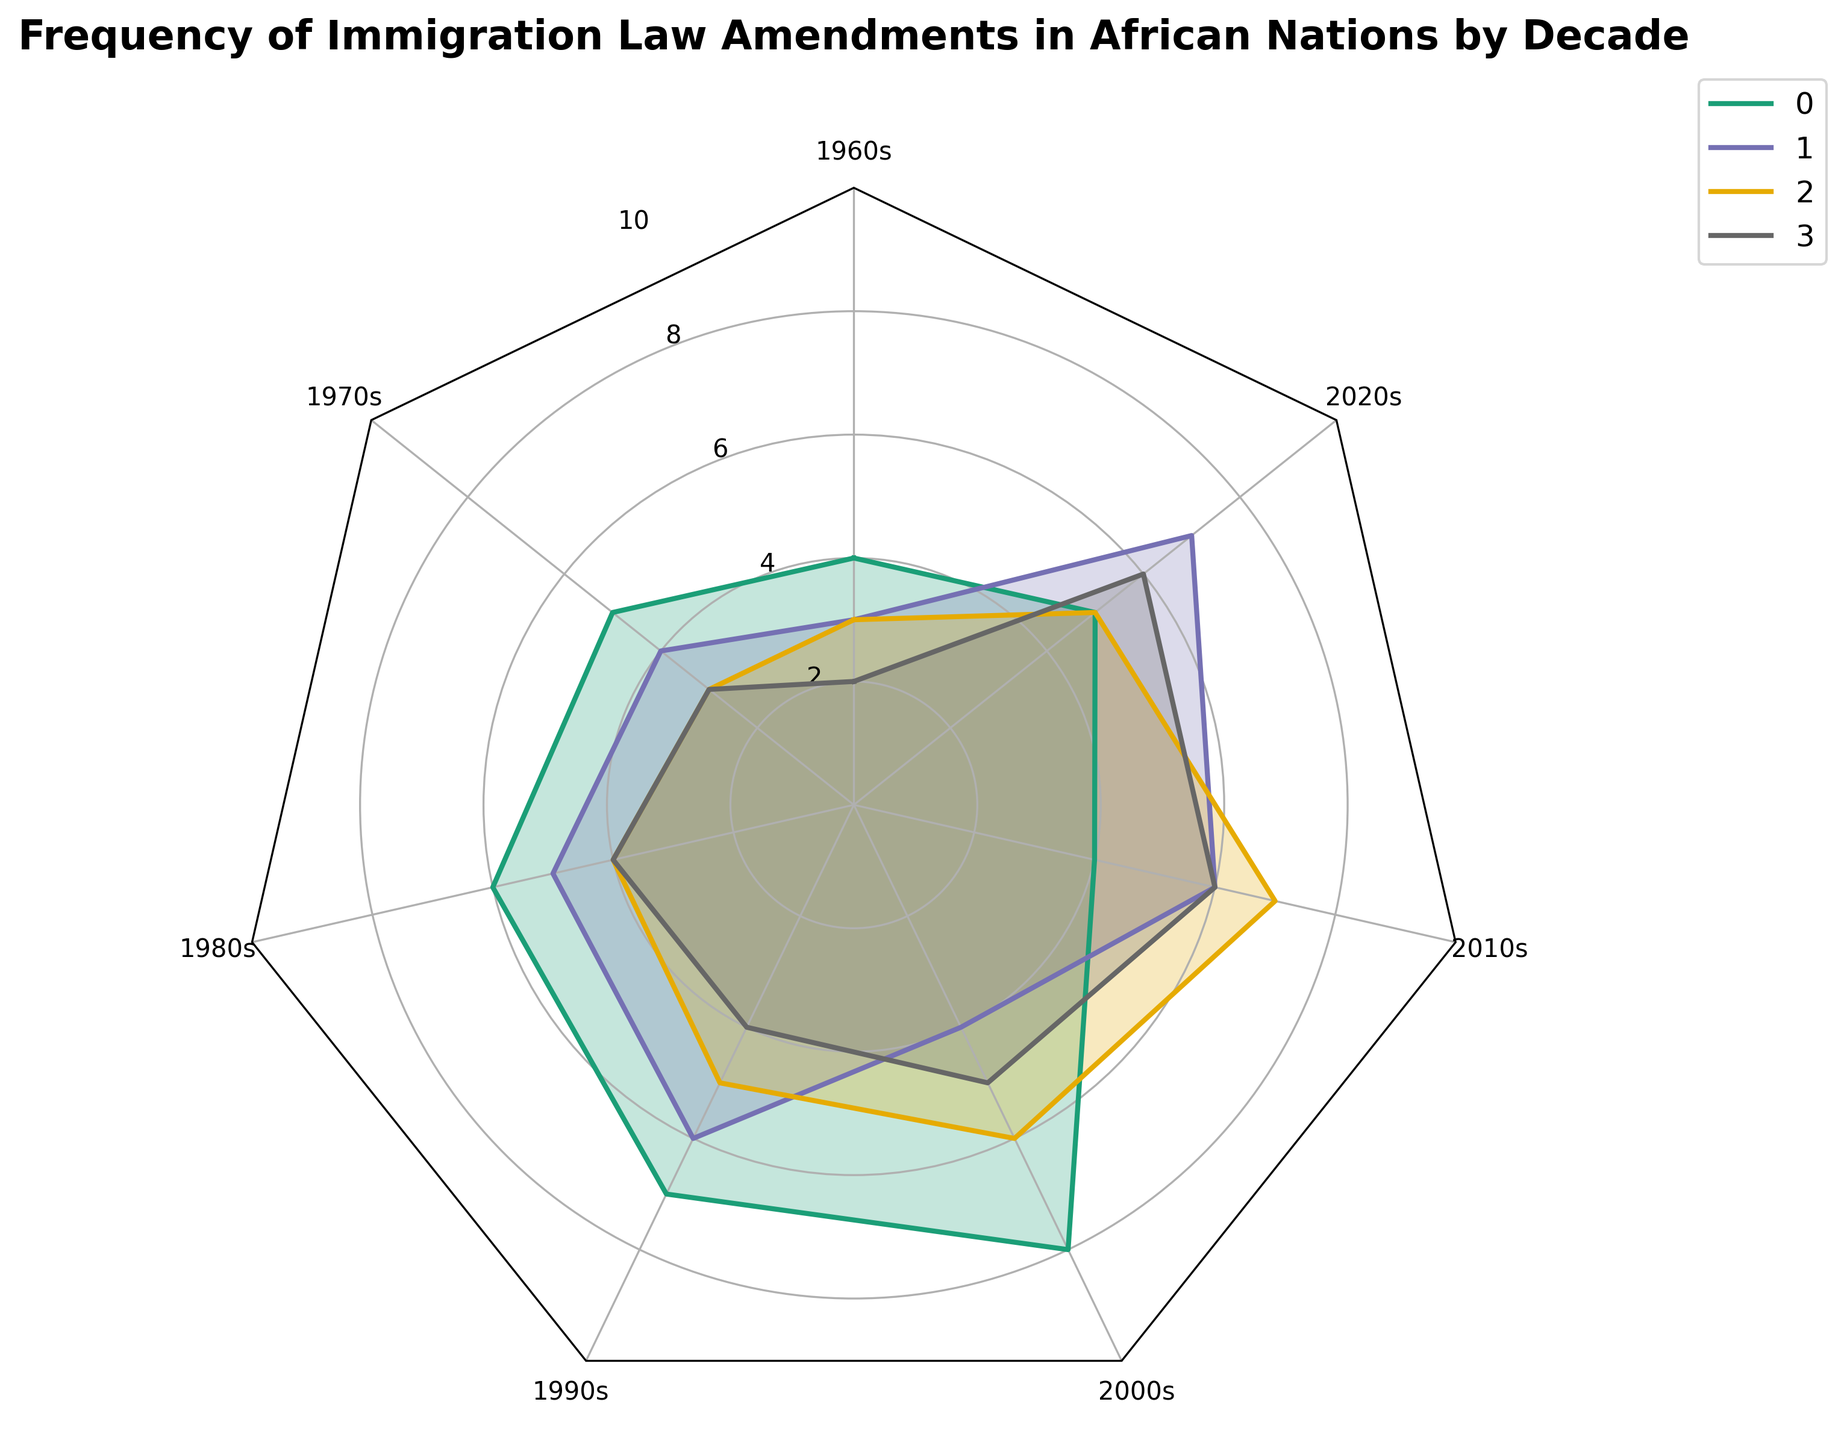What is the title of the radar chart? The title is typically found at the top of the chart and summarizes the content. Here, it reads "Frequency of Immigration Law Amendments in African Nations by Decade".
Answer: Frequency of Immigration Law Amendments in African Nations by Decade Which country had the highest frequency of immigration law amendments in the 2000s? Look at the 2000s axis and observe the values for each country. Nigeria's value is 8, which is the highest compared to the other countries.
Answer: Nigeria What is the range of values used for the y-axis on the radar chart? The y-axis range can be seen as concentric circles with labeled ticks around the chart. The labels show it ranges from 0 to 10.
Answer: 0 to 10 Which country showed the least frequency of immigration law amendments in the 1960s? By comparing the values on the 1960s axis, Ghana has a value of 2, which is the smallest among the countries listed.
Answer: Ghana How did Kenya's frequency of immigration law amendments change between the 1990s and the 2000s? Check the values for Kenya on the 1990s and 2000s axes. In the 1990s, the value is 5, and in the 2000s, it's 6. The change is 6 - 5 = 1.
Answer: Increased by 1 Which decade shows the highest frequencies across most countries? Observe the spikes for each country across different decades. The 2000s generally exhibit the highest values for most countries except for South Africa.
Answer: 2000s Compare the frequency trend for South Africa and Kenya across the decades. Which has more fluctuations? Evaluate the frequency values for both countries across all decades. South Africa's values go from 3, 4, 5, 6, 4, 6, 7, while Kenya's values are 3, 3, 4, 5, 6, 7, 5. South Africa has more fluctuations as its values increase and decrease more variably compared to Kenya's steady increase.
Answer: South Africa What is the average frequency of immigration law amendments for Ghana in the decades shown on the radar chart? Add Ghana's values across the decades (2, 3, 4, 4, 5, 6, 6) and divide by the number of decades (7). (2 + 3 + 4 + 4 + 5 + 6 + 6) / 7 = 30 / 7 ≈ 4.29.
Answer: 4.29 Which two countries showed the same frequency of law amendments in the 2020s? Look at the 2020s axis and compare the values. Both Nigeria and Kenya show a value of 5.
Answer: Nigeria and Kenya 